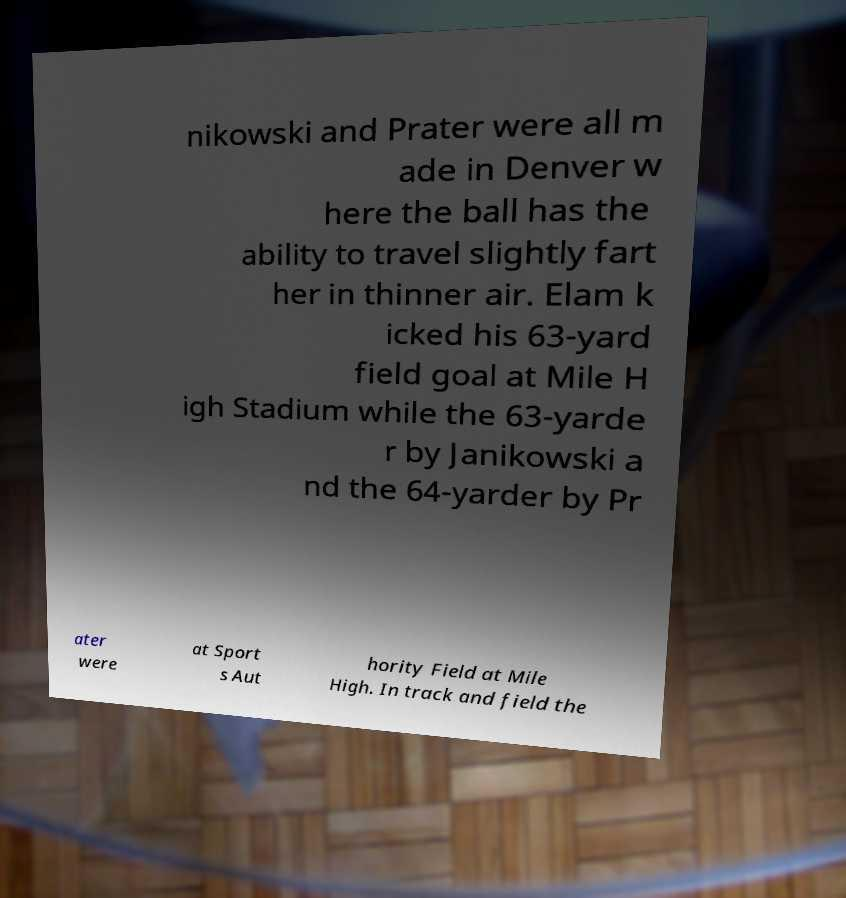There's text embedded in this image that I need extracted. Can you transcribe it verbatim? nikowski and Prater were all m ade in Denver w here the ball has the ability to travel slightly fart her in thinner air. Elam k icked his 63-yard field goal at Mile H igh Stadium while the 63-yarde r by Janikowski a nd the 64-yarder by Pr ater were at Sport s Aut hority Field at Mile High. In track and field the 